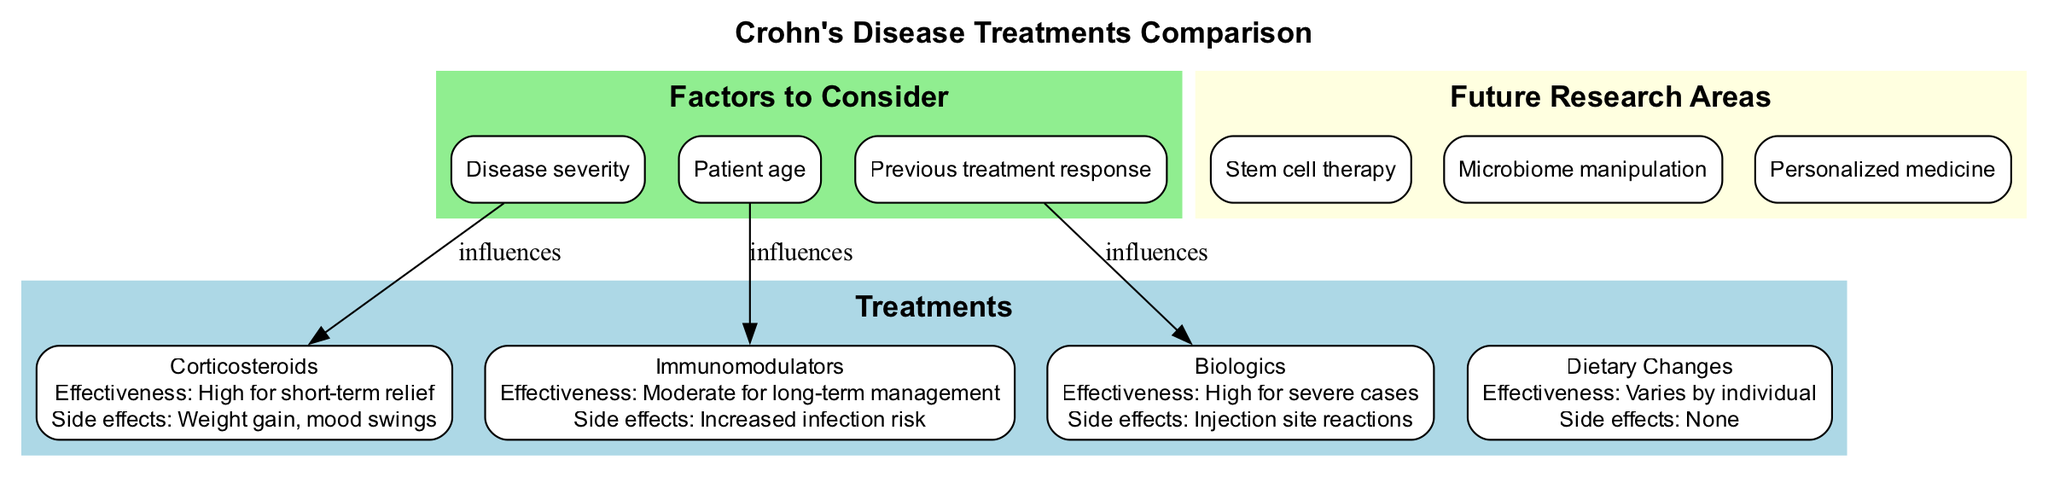What is the effectiveness of Corticosteroids? The diagram states that Corticosteroids provide "High for short-term relief" in terms of effectiveness, which is the specific information listed under this treatment.
Answer: High for short-term relief What are the side effects of Immunomodulators? According to the diagram, Immunomodulators have "Increased infection risk" listed as their side effects, which directly answers the question about their side effects.
Answer: Increased infection risk How many treatments are listed in the diagram? The diagram includes four treatments: Corticosteroids, Immunomodulators, Biologics, and Dietary Changes. Counting these gives us a total of four treatments.
Answer: 4 Which factor influences Biologics? The diagram specifies that "Previous treatment response" influences Biologics, indicating a direct relationship between this factor and the treatment method.
Answer: Previous treatment response What is the effectiveness of Dietary Changes? The effectiveness of Dietary Changes as indicated in the diagram is "Varies by individual," which shows that the result can differ from one patient to another.
Answer: Varies by individual Which treatment has the least specified effectiveness? The least specified effectiveness in the diagram is that of Dietary Changes, where it states that the effectiveness "Varies by individual," compared to other treatments that state specific effectiveness levels.
Answer: Varies by individual Which research area is mentioned as a future direction? The diagram highlights "Stem cell therapy," "Microbiome manipulation," and "Personalized medicine" as future research areas. Any of these can be correct, but "Stem cell therapy" is specifically listed first.
Answer: Stem cell therapy Which treatment has no side effects listed? The diagram indicates that Dietary Changes have "None" listed as side effects, suggesting that this treatment does not lead to any adverse effects.
Answer: None What color represents the Treatments section in the diagram? The Treatments section is filled with the color "lightblue," as specified in the diagram's attributes.
Answer: lightblue 